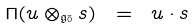<formula> <loc_0><loc_0><loc_500><loc_500>\Pi ( u \otimes _ { \mathfrak { g } _ { \bar { 0 } } } s ) \ = \ u \cdot s</formula> 